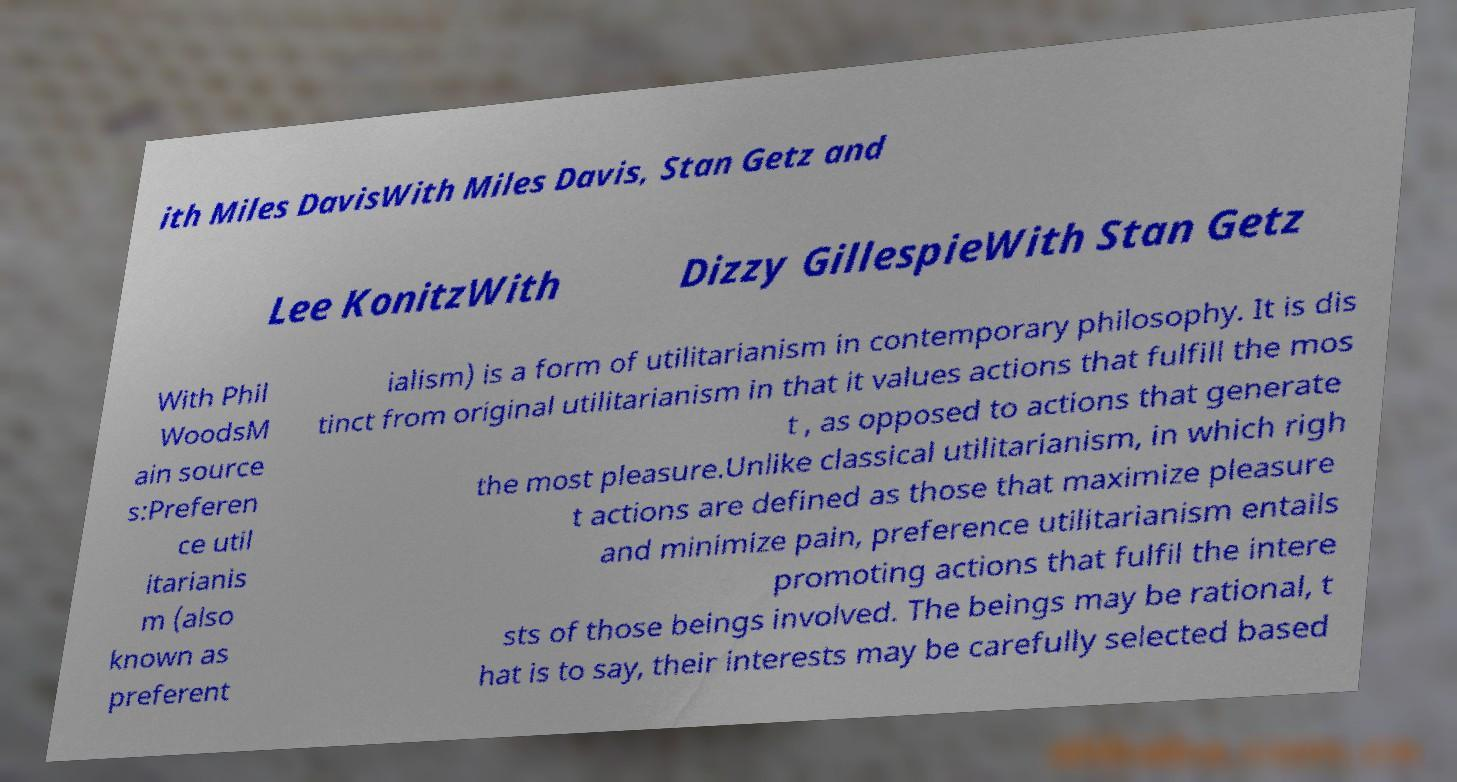There's text embedded in this image that I need extracted. Can you transcribe it verbatim? ith Miles DavisWith Miles Davis, Stan Getz and Lee KonitzWith Dizzy GillespieWith Stan Getz With Phil WoodsM ain source s:Preferen ce util itarianis m (also known as preferent ialism) is a form of utilitarianism in contemporary philosophy. It is dis tinct from original utilitarianism in that it values actions that fulfill the mos t , as opposed to actions that generate the most pleasure.Unlike classical utilitarianism, in which righ t actions are defined as those that maximize pleasure and minimize pain, preference utilitarianism entails promoting actions that fulfil the intere sts of those beings involved. The beings may be rational, t hat is to say, their interests may be carefully selected based 